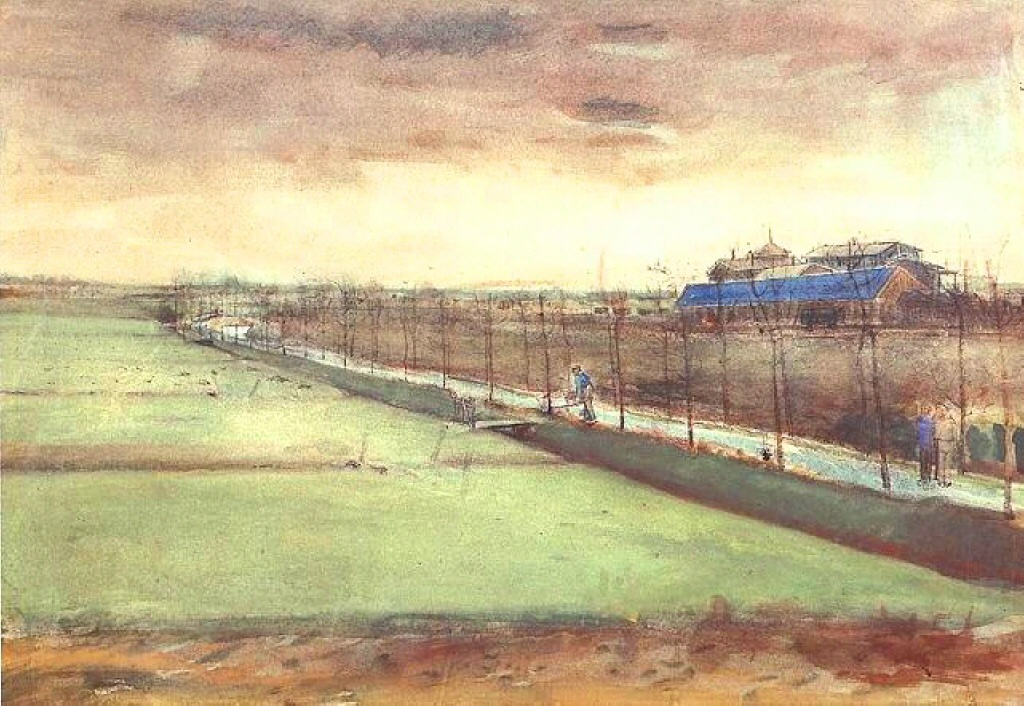What does the presence of figures add to this scene? The faintly depicted figures in the artwork add a layer of narrative to the scene, suggesting daily activity and the presence of life within this rural setting. Their inclusion makes the landscape more relatable and vibrant, hinting at stories and routines that are unfolding even in such a tranquil environment. They serve as a human connection within the broad strokes of nature, subtly inviting viewers to think about the human aspect of rural life. Could these figures be locals or just passersby? It's more plausible that these figures are locals, as their casual presence and position within the landscape suggest familiarity and a routine presence. They might be involved in day-to-day agricultural activities or simply enjoying the landscape, which leans towards them being residents of this area rather than occasional visitors. 